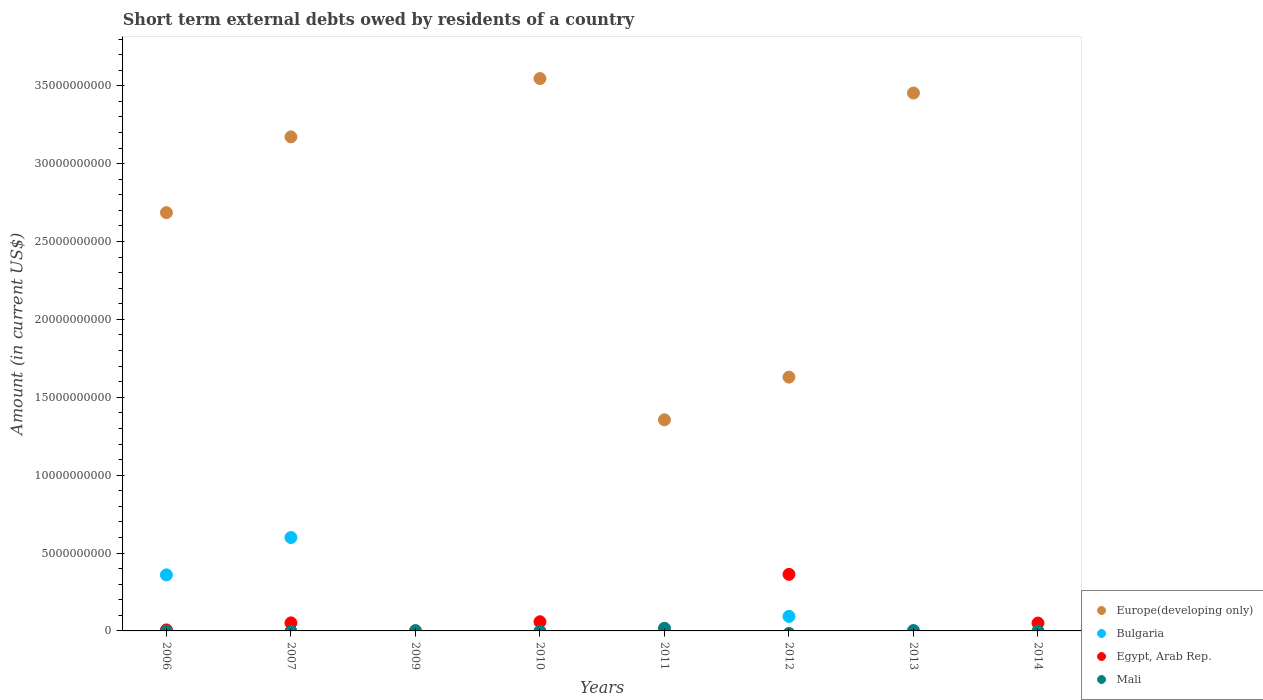Is the number of dotlines equal to the number of legend labels?
Keep it short and to the point. No. What is the amount of short-term external debts owed by residents in Mali in 2011?
Ensure brevity in your answer.  1.69e+08. Across all years, what is the maximum amount of short-term external debts owed by residents in Egypt, Arab Rep.?
Offer a very short reply. 3.63e+09. Across all years, what is the minimum amount of short-term external debts owed by residents in Bulgaria?
Ensure brevity in your answer.  0. In which year was the amount of short-term external debts owed by residents in Egypt, Arab Rep. maximum?
Offer a very short reply. 2012. What is the total amount of short-term external debts owed by residents in Egypt, Arab Rep. in the graph?
Ensure brevity in your answer.  5.31e+09. What is the difference between the amount of short-term external debts owed by residents in Europe(developing only) in 2011 and that in 2012?
Your answer should be very brief. -2.74e+09. What is the difference between the amount of short-term external debts owed by residents in Egypt, Arab Rep. in 2014 and the amount of short-term external debts owed by residents in Mali in 2007?
Offer a very short reply. 5.05e+08. What is the average amount of short-term external debts owed by residents in Bulgaria per year?
Give a very brief answer. 1.32e+09. In the year 2006, what is the difference between the amount of short-term external debts owed by residents in Bulgaria and amount of short-term external debts owed by residents in Europe(developing only)?
Your answer should be very brief. -2.33e+1. What is the ratio of the amount of short-term external debts owed by residents in Egypt, Arab Rep. in 2010 to that in 2014?
Make the answer very short. 1.17. Is the amount of short-term external debts owed by residents in Europe(developing only) in 2007 less than that in 2010?
Provide a short and direct response. Yes. What is the difference between the highest and the second highest amount of short-term external debts owed by residents in Europe(developing only)?
Provide a short and direct response. 9.26e+08. What is the difference between the highest and the lowest amount of short-term external debts owed by residents in Mali?
Your answer should be very brief. 1.69e+08. In how many years, is the amount of short-term external debts owed by residents in Bulgaria greater than the average amount of short-term external debts owed by residents in Bulgaria taken over all years?
Offer a very short reply. 2. Is the sum of the amount of short-term external debts owed by residents in Europe(developing only) in 2011 and 2013 greater than the maximum amount of short-term external debts owed by residents in Egypt, Arab Rep. across all years?
Ensure brevity in your answer.  Yes. Is it the case that in every year, the sum of the amount of short-term external debts owed by residents in Mali and amount of short-term external debts owed by residents in Europe(developing only)  is greater than the sum of amount of short-term external debts owed by residents in Bulgaria and amount of short-term external debts owed by residents in Egypt, Arab Rep.?
Make the answer very short. No. Is it the case that in every year, the sum of the amount of short-term external debts owed by residents in Bulgaria and amount of short-term external debts owed by residents in Egypt, Arab Rep.  is greater than the amount of short-term external debts owed by residents in Mali?
Provide a short and direct response. No. How many years are there in the graph?
Your answer should be compact. 8. What is the difference between two consecutive major ticks on the Y-axis?
Your response must be concise. 5.00e+09. Are the values on the major ticks of Y-axis written in scientific E-notation?
Offer a very short reply. No. Does the graph contain grids?
Provide a short and direct response. No. Where does the legend appear in the graph?
Your answer should be compact. Bottom right. How are the legend labels stacked?
Your answer should be compact. Vertical. What is the title of the graph?
Ensure brevity in your answer.  Short term external debts owed by residents of a country. What is the label or title of the X-axis?
Make the answer very short. Years. What is the Amount (in current US$) in Europe(developing only) in 2006?
Provide a short and direct response. 2.69e+1. What is the Amount (in current US$) of Bulgaria in 2006?
Offer a terse response. 3.60e+09. What is the Amount (in current US$) in Egypt, Arab Rep. in 2006?
Your answer should be compact. 6.50e+07. What is the Amount (in current US$) in Europe(developing only) in 2007?
Your answer should be very brief. 3.17e+1. What is the Amount (in current US$) in Bulgaria in 2007?
Provide a succinct answer. 6.00e+09. What is the Amount (in current US$) of Egypt, Arab Rep. in 2007?
Your answer should be very brief. 5.16e+08. What is the Amount (in current US$) of Mali in 2007?
Ensure brevity in your answer.  0. What is the Amount (in current US$) of Egypt, Arab Rep. in 2009?
Offer a very short reply. 0. What is the Amount (in current US$) of Mali in 2009?
Offer a very short reply. 2.40e+07. What is the Amount (in current US$) of Europe(developing only) in 2010?
Provide a succinct answer. 3.55e+1. What is the Amount (in current US$) in Bulgaria in 2010?
Provide a succinct answer. 0. What is the Amount (in current US$) of Egypt, Arab Rep. in 2010?
Your response must be concise. 5.88e+08. What is the Amount (in current US$) of Europe(developing only) in 2011?
Provide a short and direct response. 1.36e+1. What is the Amount (in current US$) of Bulgaria in 2011?
Make the answer very short. 0. What is the Amount (in current US$) of Mali in 2011?
Provide a succinct answer. 1.69e+08. What is the Amount (in current US$) of Europe(developing only) in 2012?
Ensure brevity in your answer.  1.63e+1. What is the Amount (in current US$) in Bulgaria in 2012?
Keep it short and to the point. 9.32e+08. What is the Amount (in current US$) in Egypt, Arab Rep. in 2012?
Your answer should be compact. 3.63e+09. What is the Amount (in current US$) of Europe(developing only) in 2013?
Make the answer very short. 3.45e+1. What is the Amount (in current US$) of Bulgaria in 2013?
Provide a short and direct response. 0. What is the Amount (in current US$) in Egypt, Arab Rep. in 2013?
Your response must be concise. 0. What is the Amount (in current US$) of Mali in 2013?
Provide a succinct answer. 2.50e+07. What is the Amount (in current US$) of Europe(developing only) in 2014?
Keep it short and to the point. 0. What is the Amount (in current US$) of Bulgaria in 2014?
Your response must be concise. 0. What is the Amount (in current US$) of Egypt, Arab Rep. in 2014?
Your answer should be compact. 5.05e+08. Across all years, what is the maximum Amount (in current US$) of Europe(developing only)?
Provide a short and direct response. 3.55e+1. Across all years, what is the maximum Amount (in current US$) in Bulgaria?
Make the answer very short. 6.00e+09. Across all years, what is the maximum Amount (in current US$) of Egypt, Arab Rep.?
Provide a short and direct response. 3.63e+09. Across all years, what is the maximum Amount (in current US$) of Mali?
Provide a succinct answer. 1.69e+08. Across all years, what is the minimum Amount (in current US$) of Europe(developing only)?
Your answer should be very brief. 0. Across all years, what is the minimum Amount (in current US$) of Bulgaria?
Your answer should be very brief. 0. Across all years, what is the minimum Amount (in current US$) of Egypt, Arab Rep.?
Provide a succinct answer. 0. Across all years, what is the minimum Amount (in current US$) in Mali?
Provide a succinct answer. 0. What is the total Amount (in current US$) of Europe(developing only) in the graph?
Provide a short and direct response. 1.58e+11. What is the total Amount (in current US$) in Bulgaria in the graph?
Your answer should be compact. 1.05e+1. What is the total Amount (in current US$) of Egypt, Arab Rep. in the graph?
Offer a very short reply. 5.31e+09. What is the total Amount (in current US$) in Mali in the graph?
Make the answer very short. 2.18e+08. What is the difference between the Amount (in current US$) of Europe(developing only) in 2006 and that in 2007?
Give a very brief answer. -4.87e+09. What is the difference between the Amount (in current US$) of Bulgaria in 2006 and that in 2007?
Provide a short and direct response. -2.40e+09. What is the difference between the Amount (in current US$) in Egypt, Arab Rep. in 2006 and that in 2007?
Keep it short and to the point. -4.51e+08. What is the difference between the Amount (in current US$) of Europe(developing only) in 2006 and that in 2010?
Offer a very short reply. -8.61e+09. What is the difference between the Amount (in current US$) of Egypt, Arab Rep. in 2006 and that in 2010?
Keep it short and to the point. -5.23e+08. What is the difference between the Amount (in current US$) in Europe(developing only) in 2006 and that in 2011?
Give a very brief answer. 1.33e+1. What is the difference between the Amount (in current US$) of Europe(developing only) in 2006 and that in 2012?
Keep it short and to the point. 1.06e+1. What is the difference between the Amount (in current US$) in Bulgaria in 2006 and that in 2012?
Offer a very short reply. 2.67e+09. What is the difference between the Amount (in current US$) of Egypt, Arab Rep. in 2006 and that in 2012?
Your response must be concise. -3.57e+09. What is the difference between the Amount (in current US$) of Europe(developing only) in 2006 and that in 2013?
Provide a succinct answer. -7.68e+09. What is the difference between the Amount (in current US$) in Egypt, Arab Rep. in 2006 and that in 2014?
Provide a succinct answer. -4.40e+08. What is the difference between the Amount (in current US$) of Europe(developing only) in 2007 and that in 2010?
Provide a short and direct response. -3.74e+09. What is the difference between the Amount (in current US$) of Egypt, Arab Rep. in 2007 and that in 2010?
Give a very brief answer. -7.20e+07. What is the difference between the Amount (in current US$) of Europe(developing only) in 2007 and that in 2011?
Provide a short and direct response. 1.82e+1. What is the difference between the Amount (in current US$) in Europe(developing only) in 2007 and that in 2012?
Your response must be concise. 1.54e+1. What is the difference between the Amount (in current US$) in Bulgaria in 2007 and that in 2012?
Give a very brief answer. 5.06e+09. What is the difference between the Amount (in current US$) in Egypt, Arab Rep. in 2007 and that in 2012?
Your answer should be compact. -3.12e+09. What is the difference between the Amount (in current US$) in Europe(developing only) in 2007 and that in 2013?
Make the answer very short. -2.82e+09. What is the difference between the Amount (in current US$) in Egypt, Arab Rep. in 2007 and that in 2014?
Ensure brevity in your answer.  1.14e+07. What is the difference between the Amount (in current US$) in Mali in 2009 and that in 2011?
Offer a terse response. -1.45e+08. What is the difference between the Amount (in current US$) of Europe(developing only) in 2010 and that in 2011?
Offer a very short reply. 2.19e+1. What is the difference between the Amount (in current US$) of Europe(developing only) in 2010 and that in 2012?
Offer a very short reply. 1.92e+1. What is the difference between the Amount (in current US$) of Egypt, Arab Rep. in 2010 and that in 2012?
Give a very brief answer. -3.04e+09. What is the difference between the Amount (in current US$) in Europe(developing only) in 2010 and that in 2013?
Your answer should be compact. 9.26e+08. What is the difference between the Amount (in current US$) of Egypt, Arab Rep. in 2010 and that in 2014?
Your answer should be compact. 8.34e+07. What is the difference between the Amount (in current US$) of Europe(developing only) in 2011 and that in 2012?
Your answer should be compact. -2.74e+09. What is the difference between the Amount (in current US$) of Europe(developing only) in 2011 and that in 2013?
Offer a very short reply. -2.10e+1. What is the difference between the Amount (in current US$) of Mali in 2011 and that in 2013?
Give a very brief answer. 1.44e+08. What is the difference between the Amount (in current US$) of Europe(developing only) in 2012 and that in 2013?
Offer a very short reply. -1.82e+1. What is the difference between the Amount (in current US$) in Egypt, Arab Rep. in 2012 and that in 2014?
Your response must be concise. 3.13e+09. What is the difference between the Amount (in current US$) of Europe(developing only) in 2006 and the Amount (in current US$) of Bulgaria in 2007?
Keep it short and to the point. 2.09e+1. What is the difference between the Amount (in current US$) in Europe(developing only) in 2006 and the Amount (in current US$) in Egypt, Arab Rep. in 2007?
Provide a succinct answer. 2.63e+1. What is the difference between the Amount (in current US$) of Bulgaria in 2006 and the Amount (in current US$) of Egypt, Arab Rep. in 2007?
Your response must be concise. 3.08e+09. What is the difference between the Amount (in current US$) of Europe(developing only) in 2006 and the Amount (in current US$) of Mali in 2009?
Your answer should be compact. 2.68e+1. What is the difference between the Amount (in current US$) of Bulgaria in 2006 and the Amount (in current US$) of Mali in 2009?
Provide a succinct answer. 3.57e+09. What is the difference between the Amount (in current US$) of Egypt, Arab Rep. in 2006 and the Amount (in current US$) of Mali in 2009?
Your response must be concise. 4.10e+07. What is the difference between the Amount (in current US$) in Europe(developing only) in 2006 and the Amount (in current US$) in Egypt, Arab Rep. in 2010?
Offer a very short reply. 2.63e+1. What is the difference between the Amount (in current US$) in Bulgaria in 2006 and the Amount (in current US$) in Egypt, Arab Rep. in 2010?
Ensure brevity in your answer.  3.01e+09. What is the difference between the Amount (in current US$) of Europe(developing only) in 2006 and the Amount (in current US$) of Mali in 2011?
Offer a terse response. 2.67e+1. What is the difference between the Amount (in current US$) in Bulgaria in 2006 and the Amount (in current US$) in Mali in 2011?
Your response must be concise. 3.43e+09. What is the difference between the Amount (in current US$) of Egypt, Arab Rep. in 2006 and the Amount (in current US$) of Mali in 2011?
Offer a terse response. -1.04e+08. What is the difference between the Amount (in current US$) of Europe(developing only) in 2006 and the Amount (in current US$) of Bulgaria in 2012?
Offer a terse response. 2.59e+1. What is the difference between the Amount (in current US$) in Europe(developing only) in 2006 and the Amount (in current US$) in Egypt, Arab Rep. in 2012?
Offer a very short reply. 2.32e+1. What is the difference between the Amount (in current US$) in Bulgaria in 2006 and the Amount (in current US$) in Egypt, Arab Rep. in 2012?
Make the answer very short. -3.40e+07. What is the difference between the Amount (in current US$) of Europe(developing only) in 2006 and the Amount (in current US$) of Mali in 2013?
Offer a very short reply. 2.68e+1. What is the difference between the Amount (in current US$) of Bulgaria in 2006 and the Amount (in current US$) of Mali in 2013?
Ensure brevity in your answer.  3.57e+09. What is the difference between the Amount (in current US$) in Egypt, Arab Rep. in 2006 and the Amount (in current US$) in Mali in 2013?
Give a very brief answer. 4.00e+07. What is the difference between the Amount (in current US$) in Europe(developing only) in 2006 and the Amount (in current US$) in Egypt, Arab Rep. in 2014?
Your response must be concise. 2.63e+1. What is the difference between the Amount (in current US$) in Bulgaria in 2006 and the Amount (in current US$) in Egypt, Arab Rep. in 2014?
Offer a very short reply. 3.09e+09. What is the difference between the Amount (in current US$) in Europe(developing only) in 2007 and the Amount (in current US$) in Mali in 2009?
Provide a short and direct response. 3.17e+1. What is the difference between the Amount (in current US$) in Bulgaria in 2007 and the Amount (in current US$) in Mali in 2009?
Make the answer very short. 5.97e+09. What is the difference between the Amount (in current US$) in Egypt, Arab Rep. in 2007 and the Amount (in current US$) in Mali in 2009?
Provide a succinct answer. 4.92e+08. What is the difference between the Amount (in current US$) in Europe(developing only) in 2007 and the Amount (in current US$) in Egypt, Arab Rep. in 2010?
Provide a succinct answer. 3.11e+1. What is the difference between the Amount (in current US$) of Bulgaria in 2007 and the Amount (in current US$) of Egypt, Arab Rep. in 2010?
Your answer should be very brief. 5.41e+09. What is the difference between the Amount (in current US$) in Europe(developing only) in 2007 and the Amount (in current US$) in Mali in 2011?
Make the answer very short. 3.16e+1. What is the difference between the Amount (in current US$) in Bulgaria in 2007 and the Amount (in current US$) in Mali in 2011?
Your answer should be very brief. 5.83e+09. What is the difference between the Amount (in current US$) of Egypt, Arab Rep. in 2007 and the Amount (in current US$) of Mali in 2011?
Offer a terse response. 3.47e+08. What is the difference between the Amount (in current US$) of Europe(developing only) in 2007 and the Amount (in current US$) of Bulgaria in 2012?
Your answer should be very brief. 3.08e+1. What is the difference between the Amount (in current US$) of Europe(developing only) in 2007 and the Amount (in current US$) of Egypt, Arab Rep. in 2012?
Provide a short and direct response. 2.81e+1. What is the difference between the Amount (in current US$) of Bulgaria in 2007 and the Amount (in current US$) of Egypt, Arab Rep. in 2012?
Offer a very short reply. 2.36e+09. What is the difference between the Amount (in current US$) in Europe(developing only) in 2007 and the Amount (in current US$) in Mali in 2013?
Offer a very short reply. 3.17e+1. What is the difference between the Amount (in current US$) in Bulgaria in 2007 and the Amount (in current US$) in Mali in 2013?
Your answer should be very brief. 5.97e+09. What is the difference between the Amount (in current US$) of Egypt, Arab Rep. in 2007 and the Amount (in current US$) of Mali in 2013?
Offer a very short reply. 4.91e+08. What is the difference between the Amount (in current US$) in Europe(developing only) in 2007 and the Amount (in current US$) in Egypt, Arab Rep. in 2014?
Provide a succinct answer. 3.12e+1. What is the difference between the Amount (in current US$) in Bulgaria in 2007 and the Amount (in current US$) in Egypt, Arab Rep. in 2014?
Provide a succinct answer. 5.49e+09. What is the difference between the Amount (in current US$) of Europe(developing only) in 2010 and the Amount (in current US$) of Mali in 2011?
Provide a short and direct response. 3.53e+1. What is the difference between the Amount (in current US$) in Egypt, Arab Rep. in 2010 and the Amount (in current US$) in Mali in 2011?
Provide a succinct answer. 4.19e+08. What is the difference between the Amount (in current US$) in Europe(developing only) in 2010 and the Amount (in current US$) in Bulgaria in 2012?
Make the answer very short. 3.45e+1. What is the difference between the Amount (in current US$) of Europe(developing only) in 2010 and the Amount (in current US$) of Egypt, Arab Rep. in 2012?
Provide a short and direct response. 3.18e+1. What is the difference between the Amount (in current US$) of Europe(developing only) in 2010 and the Amount (in current US$) of Mali in 2013?
Your answer should be compact. 3.54e+1. What is the difference between the Amount (in current US$) in Egypt, Arab Rep. in 2010 and the Amount (in current US$) in Mali in 2013?
Your answer should be very brief. 5.63e+08. What is the difference between the Amount (in current US$) of Europe(developing only) in 2010 and the Amount (in current US$) of Egypt, Arab Rep. in 2014?
Keep it short and to the point. 3.50e+1. What is the difference between the Amount (in current US$) in Europe(developing only) in 2011 and the Amount (in current US$) in Bulgaria in 2012?
Your response must be concise. 1.26e+1. What is the difference between the Amount (in current US$) in Europe(developing only) in 2011 and the Amount (in current US$) in Egypt, Arab Rep. in 2012?
Provide a succinct answer. 9.92e+09. What is the difference between the Amount (in current US$) in Europe(developing only) in 2011 and the Amount (in current US$) in Mali in 2013?
Provide a succinct answer. 1.35e+1. What is the difference between the Amount (in current US$) of Europe(developing only) in 2011 and the Amount (in current US$) of Egypt, Arab Rep. in 2014?
Your answer should be very brief. 1.31e+1. What is the difference between the Amount (in current US$) of Europe(developing only) in 2012 and the Amount (in current US$) of Mali in 2013?
Your answer should be compact. 1.63e+1. What is the difference between the Amount (in current US$) in Bulgaria in 2012 and the Amount (in current US$) in Mali in 2013?
Make the answer very short. 9.07e+08. What is the difference between the Amount (in current US$) of Egypt, Arab Rep. in 2012 and the Amount (in current US$) of Mali in 2013?
Offer a terse response. 3.61e+09. What is the difference between the Amount (in current US$) of Europe(developing only) in 2012 and the Amount (in current US$) of Egypt, Arab Rep. in 2014?
Ensure brevity in your answer.  1.58e+1. What is the difference between the Amount (in current US$) in Bulgaria in 2012 and the Amount (in current US$) in Egypt, Arab Rep. in 2014?
Your answer should be compact. 4.28e+08. What is the difference between the Amount (in current US$) in Europe(developing only) in 2013 and the Amount (in current US$) in Egypt, Arab Rep. in 2014?
Provide a succinct answer. 3.40e+1. What is the average Amount (in current US$) in Europe(developing only) per year?
Offer a very short reply. 1.98e+1. What is the average Amount (in current US$) in Bulgaria per year?
Keep it short and to the point. 1.32e+09. What is the average Amount (in current US$) in Egypt, Arab Rep. per year?
Offer a terse response. 6.63e+08. What is the average Amount (in current US$) in Mali per year?
Offer a terse response. 2.72e+07. In the year 2006, what is the difference between the Amount (in current US$) in Europe(developing only) and Amount (in current US$) in Bulgaria?
Provide a short and direct response. 2.33e+1. In the year 2006, what is the difference between the Amount (in current US$) of Europe(developing only) and Amount (in current US$) of Egypt, Arab Rep.?
Provide a short and direct response. 2.68e+1. In the year 2006, what is the difference between the Amount (in current US$) of Bulgaria and Amount (in current US$) of Egypt, Arab Rep.?
Ensure brevity in your answer.  3.53e+09. In the year 2007, what is the difference between the Amount (in current US$) in Europe(developing only) and Amount (in current US$) in Bulgaria?
Keep it short and to the point. 2.57e+1. In the year 2007, what is the difference between the Amount (in current US$) of Europe(developing only) and Amount (in current US$) of Egypt, Arab Rep.?
Make the answer very short. 3.12e+1. In the year 2007, what is the difference between the Amount (in current US$) of Bulgaria and Amount (in current US$) of Egypt, Arab Rep.?
Provide a succinct answer. 5.48e+09. In the year 2010, what is the difference between the Amount (in current US$) in Europe(developing only) and Amount (in current US$) in Egypt, Arab Rep.?
Make the answer very short. 3.49e+1. In the year 2011, what is the difference between the Amount (in current US$) in Europe(developing only) and Amount (in current US$) in Mali?
Provide a succinct answer. 1.34e+1. In the year 2012, what is the difference between the Amount (in current US$) in Europe(developing only) and Amount (in current US$) in Bulgaria?
Give a very brief answer. 1.54e+1. In the year 2012, what is the difference between the Amount (in current US$) in Europe(developing only) and Amount (in current US$) in Egypt, Arab Rep.?
Offer a very short reply. 1.27e+1. In the year 2012, what is the difference between the Amount (in current US$) in Bulgaria and Amount (in current US$) in Egypt, Arab Rep.?
Provide a short and direct response. -2.70e+09. In the year 2013, what is the difference between the Amount (in current US$) in Europe(developing only) and Amount (in current US$) in Mali?
Provide a succinct answer. 3.45e+1. What is the ratio of the Amount (in current US$) of Europe(developing only) in 2006 to that in 2007?
Give a very brief answer. 0.85. What is the ratio of the Amount (in current US$) in Bulgaria in 2006 to that in 2007?
Your response must be concise. 0.6. What is the ratio of the Amount (in current US$) of Egypt, Arab Rep. in 2006 to that in 2007?
Offer a very short reply. 0.13. What is the ratio of the Amount (in current US$) of Europe(developing only) in 2006 to that in 2010?
Offer a very short reply. 0.76. What is the ratio of the Amount (in current US$) of Egypt, Arab Rep. in 2006 to that in 2010?
Offer a very short reply. 0.11. What is the ratio of the Amount (in current US$) in Europe(developing only) in 2006 to that in 2011?
Your answer should be compact. 1.98. What is the ratio of the Amount (in current US$) in Europe(developing only) in 2006 to that in 2012?
Give a very brief answer. 1.65. What is the ratio of the Amount (in current US$) of Bulgaria in 2006 to that in 2012?
Your answer should be compact. 3.86. What is the ratio of the Amount (in current US$) in Egypt, Arab Rep. in 2006 to that in 2012?
Provide a succinct answer. 0.02. What is the ratio of the Amount (in current US$) in Europe(developing only) in 2006 to that in 2013?
Your answer should be compact. 0.78. What is the ratio of the Amount (in current US$) of Egypt, Arab Rep. in 2006 to that in 2014?
Offer a terse response. 0.13. What is the ratio of the Amount (in current US$) in Europe(developing only) in 2007 to that in 2010?
Your response must be concise. 0.89. What is the ratio of the Amount (in current US$) in Egypt, Arab Rep. in 2007 to that in 2010?
Your response must be concise. 0.88. What is the ratio of the Amount (in current US$) of Europe(developing only) in 2007 to that in 2011?
Ensure brevity in your answer.  2.34. What is the ratio of the Amount (in current US$) of Europe(developing only) in 2007 to that in 2012?
Ensure brevity in your answer.  1.95. What is the ratio of the Amount (in current US$) of Bulgaria in 2007 to that in 2012?
Provide a short and direct response. 6.43. What is the ratio of the Amount (in current US$) in Egypt, Arab Rep. in 2007 to that in 2012?
Offer a terse response. 0.14. What is the ratio of the Amount (in current US$) of Europe(developing only) in 2007 to that in 2013?
Offer a terse response. 0.92. What is the ratio of the Amount (in current US$) of Egypt, Arab Rep. in 2007 to that in 2014?
Provide a short and direct response. 1.02. What is the ratio of the Amount (in current US$) of Mali in 2009 to that in 2011?
Your response must be concise. 0.14. What is the ratio of the Amount (in current US$) of Mali in 2009 to that in 2013?
Your response must be concise. 0.96. What is the ratio of the Amount (in current US$) of Europe(developing only) in 2010 to that in 2011?
Offer a very short reply. 2.62. What is the ratio of the Amount (in current US$) of Europe(developing only) in 2010 to that in 2012?
Your answer should be compact. 2.18. What is the ratio of the Amount (in current US$) of Egypt, Arab Rep. in 2010 to that in 2012?
Keep it short and to the point. 0.16. What is the ratio of the Amount (in current US$) in Europe(developing only) in 2010 to that in 2013?
Your response must be concise. 1.03. What is the ratio of the Amount (in current US$) of Egypt, Arab Rep. in 2010 to that in 2014?
Offer a very short reply. 1.17. What is the ratio of the Amount (in current US$) in Europe(developing only) in 2011 to that in 2012?
Make the answer very short. 0.83. What is the ratio of the Amount (in current US$) of Europe(developing only) in 2011 to that in 2013?
Offer a very short reply. 0.39. What is the ratio of the Amount (in current US$) in Mali in 2011 to that in 2013?
Your response must be concise. 6.76. What is the ratio of the Amount (in current US$) in Europe(developing only) in 2012 to that in 2013?
Provide a succinct answer. 0.47. What is the ratio of the Amount (in current US$) of Egypt, Arab Rep. in 2012 to that in 2014?
Your response must be concise. 7.2. What is the difference between the highest and the second highest Amount (in current US$) in Europe(developing only)?
Give a very brief answer. 9.26e+08. What is the difference between the highest and the second highest Amount (in current US$) of Bulgaria?
Give a very brief answer. 2.40e+09. What is the difference between the highest and the second highest Amount (in current US$) of Egypt, Arab Rep.?
Your answer should be very brief. 3.04e+09. What is the difference between the highest and the second highest Amount (in current US$) of Mali?
Keep it short and to the point. 1.44e+08. What is the difference between the highest and the lowest Amount (in current US$) of Europe(developing only)?
Your answer should be very brief. 3.55e+1. What is the difference between the highest and the lowest Amount (in current US$) in Bulgaria?
Make the answer very short. 6.00e+09. What is the difference between the highest and the lowest Amount (in current US$) of Egypt, Arab Rep.?
Provide a succinct answer. 3.63e+09. What is the difference between the highest and the lowest Amount (in current US$) of Mali?
Make the answer very short. 1.69e+08. 